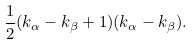<formula> <loc_0><loc_0><loc_500><loc_500>\frac { 1 } { 2 } ( k _ { \alpha } - k _ { \beta } + 1 ) ( k _ { \alpha } - k _ { \beta } ) .</formula> 